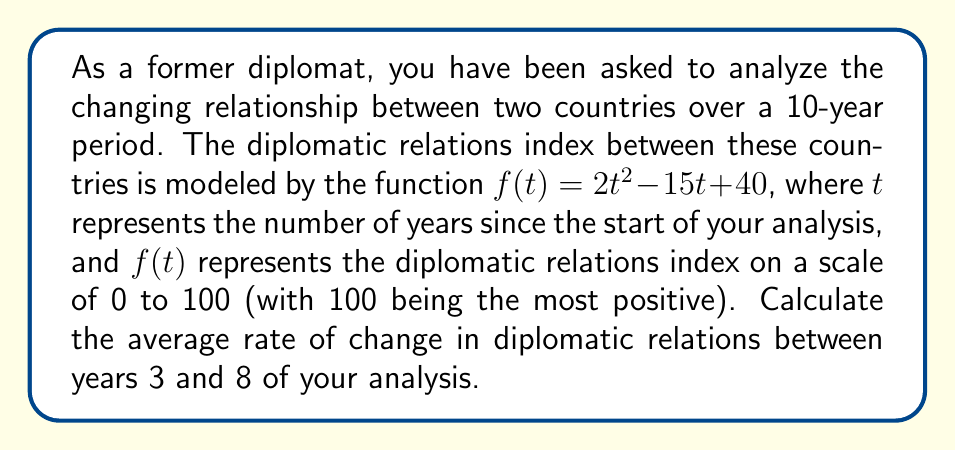What is the answer to this math problem? To calculate the average rate of change between two points, we use the formula:

$$\text{Average rate of change} = \frac{f(b) - f(a)}{b - a}$$

Where $a$ and $b$ are the two points in time we're considering.

In this case, $a = 3$ and $b = 8$.

Let's calculate $f(3)$ and $f(8)$:

$f(3) = 2(3)^2 - 15(3) + 40 = 2(9) - 45 + 40 = 18 - 45 + 40 = 13$

$f(8) = 2(8)^2 - 15(8) + 40 = 2(64) - 120 + 40 = 128 - 120 + 40 = 48$

Now we can substitute these values into our average rate of change formula:

$$\text{Average rate of change} = \frac{f(8) - f(3)}{8 - 3} = \frac{48 - 13}{5} = \frac{35}{5} = 7$$

This means that, on average, the diplomatic relations index increased by 7 points per year between years 3 and 8 of the analysis.
Answer: The average rate of change in diplomatic relations between years 3 and 8 is 7 points per year. 